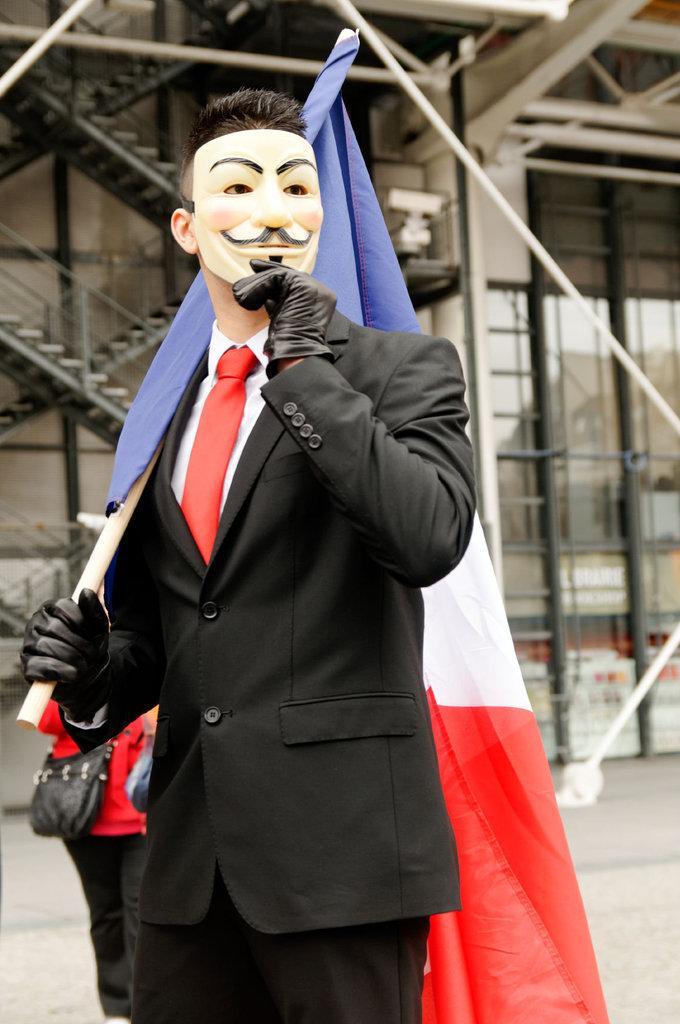How would you summarize this image in a sentence or two? In this picture we can see few people, in the middle of the image we can see a man, he wore a mask and he is holding a flag, in the background we can see few metal rods. 